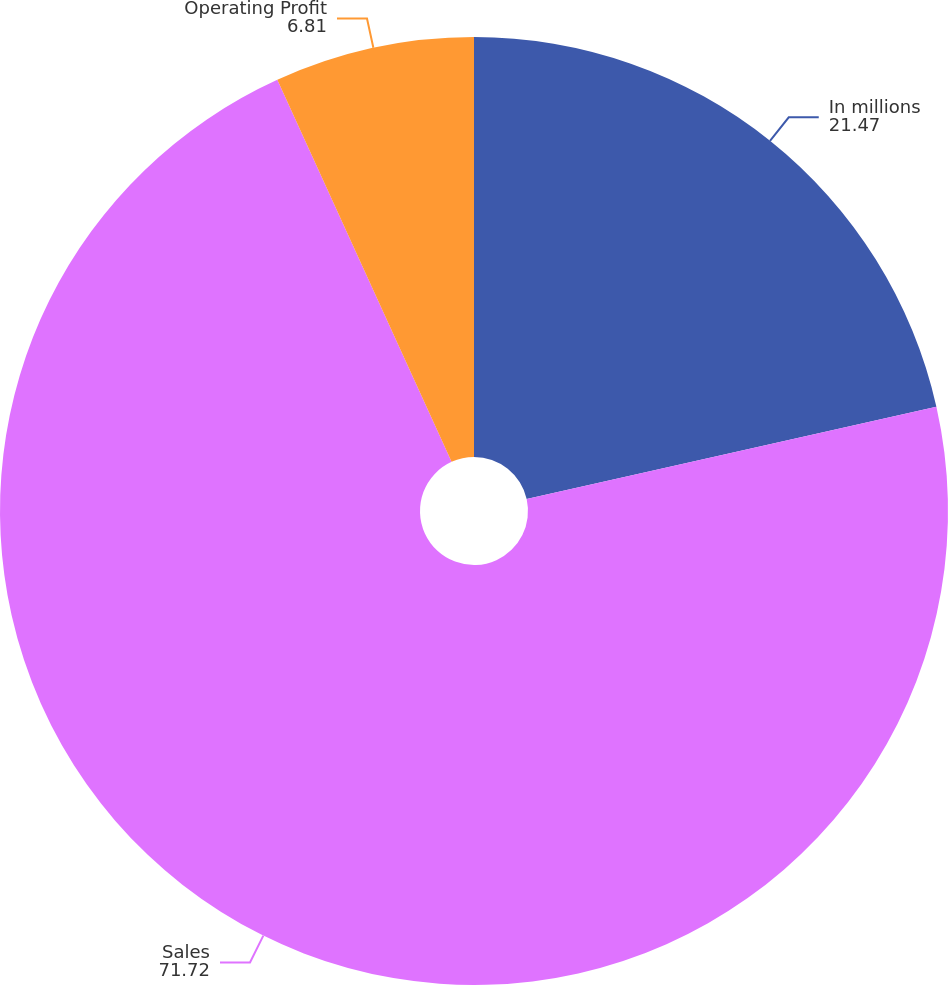Convert chart to OTSL. <chart><loc_0><loc_0><loc_500><loc_500><pie_chart><fcel>In millions<fcel>Sales<fcel>Operating Profit<nl><fcel>21.47%<fcel>71.72%<fcel>6.81%<nl></chart> 